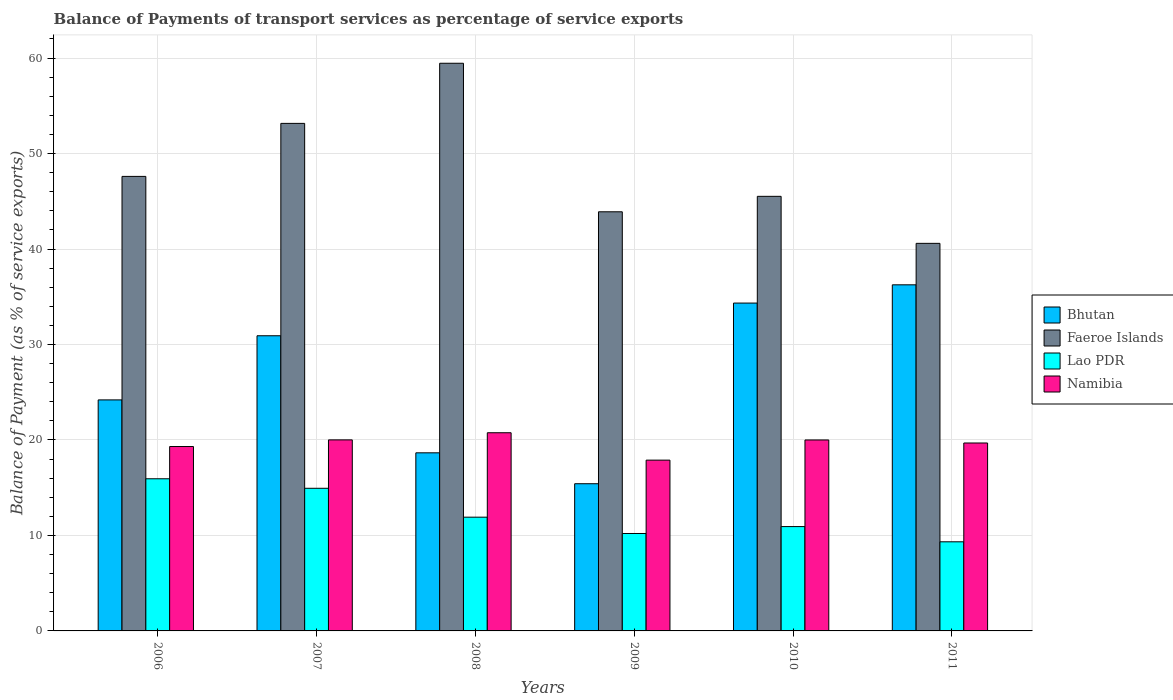How many different coloured bars are there?
Make the answer very short. 4. Are the number of bars per tick equal to the number of legend labels?
Provide a short and direct response. Yes. Are the number of bars on each tick of the X-axis equal?
Your answer should be compact. Yes. In how many cases, is the number of bars for a given year not equal to the number of legend labels?
Offer a very short reply. 0. What is the balance of payments of transport services in Faeroe Islands in 2007?
Offer a very short reply. 53.16. Across all years, what is the maximum balance of payments of transport services in Faeroe Islands?
Offer a very short reply. 59.46. Across all years, what is the minimum balance of payments of transport services in Faeroe Islands?
Your answer should be very brief. 40.59. In which year was the balance of payments of transport services in Faeroe Islands minimum?
Make the answer very short. 2011. What is the total balance of payments of transport services in Faeroe Islands in the graph?
Offer a terse response. 290.24. What is the difference between the balance of payments of transport services in Faeroe Islands in 2009 and that in 2010?
Provide a succinct answer. -1.62. What is the difference between the balance of payments of transport services in Lao PDR in 2011 and the balance of payments of transport services in Namibia in 2010?
Make the answer very short. -10.67. What is the average balance of payments of transport services in Faeroe Islands per year?
Ensure brevity in your answer.  48.37. In the year 2010, what is the difference between the balance of payments of transport services in Bhutan and balance of payments of transport services in Namibia?
Provide a succinct answer. 14.34. What is the ratio of the balance of payments of transport services in Bhutan in 2006 to that in 2011?
Make the answer very short. 0.67. Is the balance of payments of transport services in Namibia in 2007 less than that in 2008?
Provide a short and direct response. Yes. Is the difference between the balance of payments of transport services in Bhutan in 2007 and 2008 greater than the difference between the balance of payments of transport services in Namibia in 2007 and 2008?
Provide a short and direct response. Yes. What is the difference between the highest and the second highest balance of payments of transport services in Namibia?
Keep it short and to the point. 0.75. What is the difference between the highest and the lowest balance of payments of transport services in Namibia?
Your response must be concise. 2.87. Is the sum of the balance of payments of transport services in Lao PDR in 2007 and 2010 greater than the maximum balance of payments of transport services in Bhutan across all years?
Offer a terse response. No. What does the 4th bar from the left in 2007 represents?
Give a very brief answer. Namibia. What does the 3rd bar from the right in 2009 represents?
Provide a short and direct response. Faeroe Islands. How many bars are there?
Provide a succinct answer. 24. What is the difference between two consecutive major ticks on the Y-axis?
Make the answer very short. 10. Are the values on the major ticks of Y-axis written in scientific E-notation?
Ensure brevity in your answer.  No. Does the graph contain any zero values?
Provide a succinct answer. No. Does the graph contain grids?
Offer a very short reply. Yes. How many legend labels are there?
Provide a succinct answer. 4. How are the legend labels stacked?
Provide a short and direct response. Vertical. What is the title of the graph?
Provide a short and direct response. Balance of Payments of transport services as percentage of service exports. What is the label or title of the X-axis?
Provide a short and direct response. Years. What is the label or title of the Y-axis?
Your response must be concise. Balance of Payment (as % of service exports). What is the Balance of Payment (as % of service exports) in Bhutan in 2006?
Your response must be concise. 24.2. What is the Balance of Payment (as % of service exports) in Faeroe Islands in 2006?
Provide a short and direct response. 47.61. What is the Balance of Payment (as % of service exports) of Lao PDR in 2006?
Your answer should be very brief. 15.94. What is the Balance of Payment (as % of service exports) of Namibia in 2006?
Your answer should be compact. 19.31. What is the Balance of Payment (as % of service exports) of Bhutan in 2007?
Offer a terse response. 30.92. What is the Balance of Payment (as % of service exports) in Faeroe Islands in 2007?
Ensure brevity in your answer.  53.16. What is the Balance of Payment (as % of service exports) in Lao PDR in 2007?
Offer a very short reply. 14.94. What is the Balance of Payment (as % of service exports) in Namibia in 2007?
Provide a short and direct response. 20.01. What is the Balance of Payment (as % of service exports) of Bhutan in 2008?
Ensure brevity in your answer.  18.65. What is the Balance of Payment (as % of service exports) in Faeroe Islands in 2008?
Give a very brief answer. 59.46. What is the Balance of Payment (as % of service exports) in Lao PDR in 2008?
Provide a succinct answer. 11.91. What is the Balance of Payment (as % of service exports) in Namibia in 2008?
Provide a short and direct response. 20.76. What is the Balance of Payment (as % of service exports) of Bhutan in 2009?
Offer a terse response. 15.42. What is the Balance of Payment (as % of service exports) of Faeroe Islands in 2009?
Give a very brief answer. 43.9. What is the Balance of Payment (as % of service exports) of Lao PDR in 2009?
Make the answer very short. 10.2. What is the Balance of Payment (as % of service exports) of Namibia in 2009?
Offer a terse response. 17.89. What is the Balance of Payment (as % of service exports) in Bhutan in 2010?
Offer a terse response. 34.34. What is the Balance of Payment (as % of service exports) in Faeroe Islands in 2010?
Provide a succinct answer. 45.52. What is the Balance of Payment (as % of service exports) of Lao PDR in 2010?
Make the answer very short. 10.93. What is the Balance of Payment (as % of service exports) in Namibia in 2010?
Provide a short and direct response. 20. What is the Balance of Payment (as % of service exports) in Bhutan in 2011?
Your answer should be compact. 36.25. What is the Balance of Payment (as % of service exports) in Faeroe Islands in 2011?
Provide a succinct answer. 40.59. What is the Balance of Payment (as % of service exports) of Lao PDR in 2011?
Offer a very short reply. 9.33. What is the Balance of Payment (as % of service exports) of Namibia in 2011?
Offer a very short reply. 19.68. Across all years, what is the maximum Balance of Payment (as % of service exports) of Bhutan?
Ensure brevity in your answer.  36.25. Across all years, what is the maximum Balance of Payment (as % of service exports) of Faeroe Islands?
Ensure brevity in your answer.  59.46. Across all years, what is the maximum Balance of Payment (as % of service exports) in Lao PDR?
Ensure brevity in your answer.  15.94. Across all years, what is the maximum Balance of Payment (as % of service exports) of Namibia?
Your answer should be compact. 20.76. Across all years, what is the minimum Balance of Payment (as % of service exports) in Bhutan?
Ensure brevity in your answer.  15.42. Across all years, what is the minimum Balance of Payment (as % of service exports) in Faeroe Islands?
Keep it short and to the point. 40.59. Across all years, what is the minimum Balance of Payment (as % of service exports) of Lao PDR?
Provide a succinct answer. 9.33. Across all years, what is the minimum Balance of Payment (as % of service exports) in Namibia?
Offer a very short reply. 17.89. What is the total Balance of Payment (as % of service exports) in Bhutan in the graph?
Your answer should be very brief. 159.78. What is the total Balance of Payment (as % of service exports) of Faeroe Islands in the graph?
Your response must be concise. 290.24. What is the total Balance of Payment (as % of service exports) in Lao PDR in the graph?
Offer a very short reply. 73.25. What is the total Balance of Payment (as % of service exports) in Namibia in the graph?
Make the answer very short. 117.66. What is the difference between the Balance of Payment (as % of service exports) in Bhutan in 2006 and that in 2007?
Offer a very short reply. -6.72. What is the difference between the Balance of Payment (as % of service exports) in Faeroe Islands in 2006 and that in 2007?
Keep it short and to the point. -5.55. What is the difference between the Balance of Payment (as % of service exports) of Namibia in 2006 and that in 2007?
Your answer should be very brief. -0.7. What is the difference between the Balance of Payment (as % of service exports) in Bhutan in 2006 and that in 2008?
Provide a succinct answer. 5.54. What is the difference between the Balance of Payment (as % of service exports) of Faeroe Islands in 2006 and that in 2008?
Provide a short and direct response. -11.85. What is the difference between the Balance of Payment (as % of service exports) in Lao PDR in 2006 and that in 2008?
Your response must be concise. 4.02. What is the difference between the Balance of Payment (as % of service exports) in Namibia in 2006 and that in 2008?
Ensure brevity in your answer.  -1.44. What is the difference between the Balance of Payment (as % of service exports) of Bhutan in 2006 and that in 2009?
Give a very brief answer. 8.78. What is the difference between the Balance of Payment (as % of service exports) of Faeroe Islands in 2006 and that in 2009?
Offer a very short reply. 3.71. What is the difference between the Balance of Payment (as % of service exports) of Lao PDR in 2006 and that in 2009?
Give a very brief answer. 5.73. What is the difference between the Balance of Payment (as % of service exports) in Namibia in 2006 and that in 2009?
Your response must be concise. 1.43. What is the difference between the Balance of Payment (as % of service exports) of Bhutan in 2006 and that in 2010?
Your answer should be compact. -10.14. What is the difference between the Balance of Payment (as % of service exports) of Faeroe Islands in 2006 and that in 2010?
Keep it short and to the point. 2.09. What is the difference between the Balance of Payment (as % of service exports) of Lao PDR in 2006 and that in 2010?
Ensure brevity in your answer.  5.01. What is the difference between the Balance of Payment (as % of service exports) of Namibia in 2006 and that in 2010?
Your response must be concise. -0.69. What is the difference between the Balance of Payment (as % of service exports) in Bhutan in 2006 and that in 2011?
Your answer should be compact. -12.05. What is the difference between the Balance of Payment (as % of service exports) in Faeroe Islands in 2006 and that in 2011?
Give a very brief answer. 7.01. What is the difference between the Balance of Payment (as % of service exports) in Lao PDR in 2006 and that in 2011?
Give a very brief answer. 6.6. What is the difference between the Balance of Payment (as % of service exports) of Namibia in 2006 and that in 2011?
Provide a succinct answer. -0.37. What is the difference between the Balance of Payment (as % of service exports) in Bhutan in 2007 and that in 2008?
Keep it short and to the point. 12.26. What is the difference between the Balance of Payment (as % of service exports) of Faeroe Islands in 2007 and that in 2008?
Make the answer very short. -6.3. What is the difference between the Balance of Payment (as % of service exports) in Lao PDR in 2007 and that in 2008?
Offer a very short reply. 3.02. What is the difference between the Balance of Payment (as % of service exports) of Namibia in 2007 and that in 2008?
Your answer should be compact. -0.75. What is the difference between the Balance of Payment (as % of service exports) of Bhutan in 2007 and that in 2009?
Give a very brief answer. 15.5. What is the difference between the Balance of Payment (as % of service exports) in Faeroe Islands in 2007 and that in 2009?
Your answer should be compact. 9.26. What is the difference between the Balance of Payment (as % of service exports) in Lao PDR in 2007 and that in 2009?
Give a very brief answer. 4.73. What is the difference between the Balance of Payment (as % of service exports) of Namibia in 2007 and that in 2009?
Your answer should be very brief. 2.12. What is the difference between the Balance of Payment (as % of service exports) of Bhutan in 2007 and that in 2010?
Your response must be concise. -3.42. What is the difference between the Balance of Payment (as % of service exports) of Faeroe Islands in 2007 and that in 2010?
Your response must be concise. 7.64. What is the difference between the Balance of Payment (as % of service exports) in Lao PDR in 2007 and that in 2010?
Provide a succinct answer. 4.01. What is the difference between the Balance of Payment (as % of service exports) of Namibia in 2007 and that in 2010?
Offer a very short reply. 0.01. What is the difference between the Balance of Payment (as % of service exports) in Bhutan in 2007 and that in 2011?
Keep it short and to the point. -5.33. What is the difference between the Balance of Payment (as % of service exports) in Faeroe Islands in 2007 and that in 2011?
Keep it short and to the point. 12.57. What is the difference between the Balance of Payment (as % of service exports) of Lao PDR in 2007 and that in 2011?
Your response must be concise. 5.6. What is the difference between the Balance of Payment (as % of service exports) in Namibia in 2007 and that in 2011?
Make the answer very short. 0.33. What is the difference between the Balance of Payment (as % of service exports) of Bhutan in 2008 and that in 2009?
Make the answer very short. 3.24. What is the difference between the Balance of Payment (as % of service exports) of Faeroe Islands in 2008 and that in 2009?
Your answer should be very brief. 15.56. What is the difference between the Balance of Payment (as % of service exports) in Lao PDR in 2008 and that in 2009?
Ensure brevity in your answer.  1.71. What is the difference between the Balance of Payment (as % of service exports) of Namibia in 2008 and that in 2009?
Give a very brief answer. 2.87. What is the difference between the Balance of Payment (as % of service exports) in Bhutan in 2008 and that in 2010?
Give a very brief answer. -15.68. What is the difference between the Balance of Payment (as % of service exports) in Faeroe Islands in 2008 and that in 2010?
Ensure brevity in your answer.  13.94. What is the difference between the Balance of Payment (as % of service exports) of Lao PDR in 2008 and that in 2010?
Your response must be concise. 0.99. What is the difference between the Balance of Payment (as % of service exports) in Namibia in 2008 and that in 2010?
Offer a terse response. 0.76. What is the difference between the Balance of Payment (as % of service exports) in Bhutan in 2008 and that in 2011?
Your response must be concise. -17.6. What is the difference between the Balance of Payment (as % of service exports) in Faeroe Islands in 2008 and that in 2011?
Make the answer very short. 18.86. What is the difference between the Balance of Payment (as % of service exports) of Lao PDR in 2008 and that in 2011?
Offer a very short reply. 2.58. What is the difference between the Balance of Payment (as % of service exports) of Namibia in 2008 and that in 2011?
Give a very brief answer. 1.07. What is the difference between the Balance of Payment (as % of service exports) in Bhutan in 2009 and that in 2010?
Your answer should be compact. -18.92. What is the difference between the Balance of Payment (as % of service exports) in Faeroe Islands in 2009 and that in 2010?
Offer a very short reply. -1.62. What is the difference between the Balance of Payment (as % of service exports) in Lao PDR in 2009 and that in 2010?
Your answer should be very brief. -0.72. What is the difference between the Balance of Payment (as % of service exports) in Namibia in 2009 and that in 2010?
Your response must be concise. -2.11. What is the difference between the Balance of Payment (as % of service exports) of Bhutan in 2009 and that in 2011?
Provide a succinct answer. -20.83. What is the difference between the Balance of Payment (as % of service exports) in Faeroe Islands in 2009 and that in 2011?
Your answer should be compact. 3.31. What is the difference between the Balance of Payment (as % of service exports) in Lao PDR in 2009 and that in 2011?
Offer a terse response. 0.87. What is the difference between the Balance of Payment (as % of service exports) of Namibia in 2009 and that in 2011?
Ensure brevity in your answer.  -1.79. What is the difference between the Balance of Payment (as % of service exports) of Bhutan in 2010 and that in 2011?
Offer a very short reply. -1.91. What is the difference between the Balance of Payment (as % of service exports) in Faeroe Islands in 2010 and that in 2011?
Offer a terse response. 4.92. What is the difference between the Balance of Payment (as % of service exports) of Lao PDR in 2010 and that in 2011?
Your response must be concise. 1.59. What is the difference between the Balance of Payment (as % of service exports) of Namibia in 2010 and that in 2011?
Keep it short and to the point. 0.32. What is the difference between the Balance of Payment (as % of service exports) of Bhutan in 2006 and the Balance of Payment (as % of service exports) of Faeroe Islands in 2007?
Keep it short and to the point. -28.96. What is the difference between the Balance of Payment (as % of service exports) in Bhutan in 2006 and the Balance of Payment (as % of service exports) in Lao PDR in 2007?
Offer a very short reply. 9.26. What is the difference between the Balance of Payment (as % of service exports) of Bhutan in 2006 and the Balance of Payment (as % of service exports) of Namibia in 2007?
Keep it short and to the point. 4.19. What is the difference between the Balance of Payment (as % of service exports) in Faeroe Islands in 2006 and the Balance of Payment (as % of service exports) in Lao PDR in 2007?
Make the answer very short. 32.67. What is the difference between the Balance of Payment (as % of service exports) of Faeroe Islands in 2006 and the Balance of Payment (as % of service exports) of Namibia in 2007?
Your response must be concise. 27.6. What is the difference between the Balance of Payment (as % of service exports) of Lao PDR in 2006 and the Balance of Payment (as % of service exports) of Namibia in 2007?
Give a very brief answer. -4.07. What is the difference between the Balance of Payment (as % of service exports) of Bhutan in 2006 and the Balance of Payment (as % of service exports) of Faeroe Islands in 2008?
Your response must be concise. -35.26. What is the difference between the Balance of Payment (as % of service exports) of Bhutan in 2006 and the Balance of Payment (as % of service exports) of Lao PDR in 2008?
Your response must be concise. 12.28. What is the difference between the Balance of Payment (as % of service exports) in Bhutan in 2006 and the Balance of Payment (as % of service exports) in Namibia in 2008?
Your response must be concise. 3.44. What is the difference between the Balance of Payment (as % of service exports) in Faeroe Islands in 2006 and the Balance of Payment (as % of service exports) in Lao PDR in 2008?
Provide a succinct answer. 35.69. What is the difference between the Balance of Payment (as % of service exports) of Faeroe Islands in 2006 and the Balance of Payment (as % of service exports) of Namibia in 2008?
Ensure brevity in your answer.  26.85. What is the difference between the Balance of Payment (as % of service exports) of Lao PDR in 2006 and the Balance of Payment (as % of service exports) of Namibia in 2008?
Make the answer very short. -4.82. What is the difference between the Balance of Payment (as % of service exports) in Bhutan in 2006 and the Balance of Payment (as % of service exports) in Faeroe Islands in 2009?
Offer a terse response. -19.7. What is the difference between the Balance of Payment (as % of service exports) of Bhutan in 2006 and the Balance of Payment (as % of service exports) of Lao PDR in 2009?
Keep it short and to the point. 13.99. What is the difference between the Balance of Payment (as % of service exports) of Bhutan in 2006 and the Balance of Payment (as % of service exports) of Namibia in 2009?
Give a very brief answer. 6.31. What is the difference between the Balance of Payment (as % of service exports) in Faeroe Islands in 2006 and the Balance of Payment (as % of service exports) in Lao PDR in 2009?
Make the answer very short. 37.4. What is the difference between the Balance of Payment (as % of service exports) of Faeroe Islands in 2006 and the Balance of Payment (as % of service exports) of Namibia in 2009?
Your answer should be compact. 29.72. What is the difference between the Balance of Payment (as % of service exports) of Lao PDR in 2006 and the Balance of Payment (as % of service exports) of Namibia in 2009?
Your response must be concise. -1.95. What is the difference between the Balance of Payment (as % of service exports) of Bhutan in 2006 and the Balance of Payment (as % of service exports) of Faeroe Islands in 2010?
Ensure brevity in your answer.  -21.32. What is the difference between the Balance of Payment (as % of service exports) of Bhutan in 2006 and the Balance of Payment (as % of service exports) of Lao PDR in 2010?
Provide a succinct answer. 13.27. What is the difference between the Balance of Payment (as % of service exports) in Bhutan in 2006 and the Balance of Payment (as % of service exports) in Namibia in 2010?
Offer a terse response. 4.2. What is the difference between the Balance of Payment (as % of service exports) in Faeroe Islands in 2006 and the Balance of Payment (as % of service exports) in Lao PDR in 2010?
Offer a terse response. 36.68. What is the difference between the Balance of Payment (as % of service exports) in Faeroe Islands in 2006 and the Balance of Payment (as % of service exports) in Namibia in 2010?
Offer a very short reply. 27.6. What is the difference between the Balance of Payment (as % of service exports) of Lao PDR in 2006 and the Balance of Payment (as % of service exports) of Namibia in 2010?
Make the answer very short. -4.06. What is the difference between the Balance of Payment (as % of service exports) in Bhutan in 2006 and the Balance of Payment (as % of service exports) in Faeroe Islands in 2011?
Your answer should be very brief. -16.4. What is the difference between the Balance of Payment (as % of service exports) in Bhutan in 2006 and the Balance of Payment (as % of service exports) in Lao PDR in 2011?
Your answer should be very brief. 14.86. What is the difference between the Balance of Payment (as % of service exports) of Bhutan in 2006 and the Balance of Payment (as % of service exports) of Namibia in 2011?
Offer a terse response. 4.51. What is the difference between the Balance of Payment (as % of service exports) in Faeroe Islands in 2006 and the Balance of Payment (as % of service exports) in Lao PDR in 2011?
Ensure brevity in your answer.  38.27. What is the difference between the Balance of Payment (as % of service exports) in Faeroe Islands in 2006 and the Balance of Payment (as % of service exports) in Namibia in 2011?
Provide a succinct answer. 27.92. What is the difference between the Balance of Payment (as % of service exports) of Lao PDR in 2006 and the Balance of Payment (as % of service exports) of Namibia in 2011?
Keep it short and to the point. -3.75. What is the difference between the Balance of Payment (as % of service exports) of Bhutan in 2007 and the Balance of Payment (as % of service exports) of Faeroe Islands in 2008?
Offer a terse response. -28.54. What is the difference between the Balance of Payment (as % of service exports) of Bhutan in 2007 and the Balance of Payment (as % of service exports) of Lao PDR in 2008?
Offer a very short reply. 19. What is the difference between the Balance of Payment (as % of service exports) in Bhutan in 2007 and the Balance of Payment (as % of service exports) in Namibia in 2008?
Your answer should be very brief. 10.16. What is the difference between the Balance of Payment (as % of service exports) in Faeroe Islands in 2007 and the Balance of Payment (as % of service exports) in Lao PDR in 2008?
Your answer should be compact. 41.25. What is the difference between the Balance of Payment (as % of service exports) in Faeroe Islands in 2007 and the Balance of Payment (as % of service exports) in Namibia in 2008?
Your response must be concise. 32.4. What is the difference between the Balance of Payment (as % of service exports) in Lao PDR in 2007 and the Balance of Payment (as % of service exports) in Namibia in 2008?
Make the answer very short. -5.82. What is the difference between the Balance of Payment (as % of service exports) in Bhutan in 2007 and the Balance of Payment (as % of service exports) in Faeroe Islands in 2009?
Your response must be concise. -12.98. What is the difference between the Balance of Payment (as % of service exports) in Bhutan in 2007 and the Balance of Payment (as % of service exports) in Lao PDR in 2009?
Your answer should be compact. 20.71. What is the difference between the Balance of Payment (as % of service exports) of Bhutan in 2007 and the Balance of Payment (as % of service exports) of Namibia in 2009?
Keep it short and to the point. 13.03. What is the difference between the Balance of Payment (as % of service exports) in Faeroe Islands in 2007 and the Balance of Payment (as % of service exports) in Lao PDR in 2009?
Your response must be concise. 42.96. What is the difference between the Balance of Payment (as % of service exports) in Faeroe Islands in 2007 and the Balance of Payment (as % of service exports) in Namibia in 2009?
Your answer should be very brief. 35.27. What is the difference between the Balance of Payment (as % of service exports) in Lao PDR in 2007 and the Balance of Payment (as % of service exports) in Namibia in 2009?
Offer a terse response. -2.95. What is the difference between the Balance of Payment (as % of service exports) in Bhutan in 2007 and the Balance of Payment (as % of service exports) in Faeroe Islands in 2010?
Offer a terse response. -14.6. What is the difference between the Balance of Payment (as % of service exports) of Bhutan in 2007 and the Balance of Payment (as % of service exports) of Lao PDR in 2010?
Your response must be concise. 19.99. What is the difference between the Balance of Payment (as % of service exports) of Bhutan in 2007 and the Balance of Payment (as % of service exports) of Namibia in 2010?
Provide a short and direct response. 10.91. What is the difference between the Balance of Payment (as % of service exports) of Faeroe Islands in 2007 and the Balance of Payment (as % of service exports) of Lao PDR in 2010?
Your answer should be compact. 42.23. What is the difference between the Balance of Payment (as % of service exports) of Faeroe Islands in 2007 and the Balance of Payment (as % of service exports) of Namibia in 2010?
Your answer should be compact. 33.16. What is the difference between the Balance of Payment (as % of service exports) in Lao PDR in 2007 and the Balance of Payment (as % of service exports) in Namibia in 2010?
Ensure brevity in your answer.  -5.06. What is the difference between the Balance of Payment (as % of service exports) of Bhutan in 2007 and the Balance of Payment (as % of service exports) of Faeroe Islands in 2011?
Give a very brief answer. -9.68. What is the difference between the Balance of Payment (as % of service exports) of Bhutan in 2007 and the Balance of Payment (as % of service exports) of Lao PDR in 2011?
Offer a very short reply. 21.58. What is the difference between the Balance of Payment (as % of service exports) in Bhutan in 2007 and the Balance of Payment (as % of service exports) in Namibia in 2011?
Offer a terse response. 11.23. What is the difference between the Balance of Payment (as % of service exports) of Faeroe Islands in 2007 and the Balance of Payment (as % of service exports) of Lao PDR in 2011?
Ensure brevity in your answer.  43.83. What is the difference between the Balance of Payment (as % of service exports) in Faeroe Islands in 2007 and the Balance of Payment (as % of service exports) in Namibia in 2011?
Keep it short and to the point. 33.48. What is the difference between the Balance of Payment (as % of service exports) in Lao PDR in 2007 and the Balance of Payment (as % of service exports) in Namibia in 2011?
Make the answer very short. -4.75. What is the difference between the Balance of Payment (as % of service exports) of Bhutan in 2008 and the Balance of Payment (as % of service exports) of Faeroe Islands in 2009?
Provide a short and direct response. -25.25. What is the difference between the Balance of Payment (as % of service exports) in Bhutan in 2008 and the Balance of Payment (as % of service exports) in Lao PDR in 2009?
Ensure brevity in your answer.  8.45. What is the difference between the Balance of Payment (as % of service exports) in Bhutan in 2008 and the Balance of Payment (as % of service exports) in Namibia in 2009?
Give a very brief answer. 0.77. What is the difference between the Balance of Payment (as % of service exports) of Faeroe Islands in 2008 and the Balance of Payment (as % of service exports) of Lao PDR in 2009?
Give a very brief answer. 49.25. What is the difference between the Balance of Payment (as % of service exports) of Faeroe Islands in 2008 and the Balance of Payment (as % of service exports) of Namibia in 2009?
Offer a terse response. 41.57. What is the difference between the Balance of Payment (as % of service exports) in Lao PDR in 2008 and the Balance of Payment (as % of service exports) in Namibia in 2009?
Ensure brevity in your answer.  -5.97. What is the difference between the Balance of Payment (as % of service exports) in Bhutan in 2008 and the Balance of Payment (as % of service exports) in Faeroe Islands in 2010?
Provide a short and direct response. -26.86. What is the difference between the Balance of Payment (as % of service exports) in Bhutan in 2008 and the Balance of Payment (as % of service exports) in Lao PDR in 2010?
Provide a short and direct response. 7.73. What is the difference between the Balance of Payment (as % of service exports) of Bhutan in 2008 and the Balance of Payment (as % of service exports) of Namibia in 2010?
Your answer should be compact. -1.35. What is the difference between the Balance of Payment (as % of service exports) of Faeroe Islands in 2008 and the Balance of Payment (as % of service exports) of Lao PDR in 2010?
Offer a very short reply. 48.53. What is the difference between the Balance of Payment (as % of service exports) of Faeroe Islands in 2008 and the Balance of Payment (as % of service exports) of Namibia in 2010?
Give a very brief answer. 39.46. What is the difference between the Balance of Payment (as % of service exports) of Lao PDR in 2008 and the Balance of Payment (as % of service exports) of Namibia in 2010?
Your response must be concise. -8.09. What is the difference between the Balance of Payment (as % of service exports) of Bhutan in 2008 and the Balance of Payment (as % of service exports) of Faeroe Islands in 2011?
Your response must be concise. -21.94. What is the difference between the Balance of Payment (as % of service exports) in Bhutan in 2008 and the Balance of Payment (as % of service exports) in Lao PDR in 2011?
Offer a terse response. 9.32. What is the difference between the Balance of Payment (as % of service exports) in Bhutan in 2008 and the Balance of Payment (as % of service exports) in Namibia in 2011?
Make the answer very short. -1.03. What is the difference between the Balance of Payment (as % of service exports) of Faeroe Islands in 2008 and the Balance of Payment (as % of service exports) of Lao PDR in 2011?
Give a very brief answer. 50.12. What is the difference between the Balance of Payment (as % of service exports) in Faeroe Islands in 2008 and the Balance of Payment (as % of service exports) in Namibia in 2011?
Provide a short and direct response. 39.77. What is the difference between the Balance of Payment (as % of service exports) of Lao PDR in 2008 and the Balance of Payment (as % of service exports) of Namibia in 2011?
Offer a terse response. -7.77. What is the difference between the Balance of Payment (as % of service exports) of Bhutan in 2009 and the Balance of Payment (as % of service exports) of Faeroe Islands in 2010?
Your answer should be compact. -30.1. What is the difference between the Balance of Payment (as % of service exports) in Bhutan in 2009 and the Balance of Payment (as % of service exports) in Lao PDR in 2010?
Make the answer very short. 4.49. What is the difference between the Balance of Payment (as % of service exports) in Bhutan in 2009 and the Balance of Payment (as % of service exports) in Namibia in 2010?
Your answer should be very brief. -4.58. What is the difference between the Balance of Payment (as % of service exports) of Faeroe Islands in 2009 and the Balance of Payment (as % of service exports) of Lao PDR in 2010?
Keep it short and to the point. 32.97. What is the difference between the Balance of Payment (as % of service exports) of Faeroe Islands in 2009 and the Balance of Payment (as % of service exports) of Namibia in 2010?
Keep it short and to the point. 23.9. What is the difference between the Balance of Payment (as % of service exports) in Lao PDR in 2009 and the Balance of Payment (as % of service exports) in Namibia in 2010?
Your answer should be very brief. -9.8. What is the difference between the Balance of Payment (as % of service exports) of Bhutan in 2009 and the Balance of Payment (as % of service exports) of Faeroe Islands in 2011?
Offer a very short reply. -25.18. What is the difference between the Balance of Payment (as % of service exports) in Bhutan in 2009 and the Balance of Payment (as % of service exports) in Lao PDR in 2011?
Your answer should be compact. 6.08. What is the difference between the Balance of Payment (as % of service exports) in Bhutan in 2009 and the Balance of Payment (as % of service exports) in Namibia in 2011?
Offer a very short reply. -4.27. What is the difference between the Balance of Payment (as % of service exports) of Faeroe Islands in 2009 and the Balance of Payment (as % of service exports) of Lao PDR in 2011?
Your response must be concise. 34.57. What is the difference between the Balance of Payment (as % of service exports) in Faeroe Islands in 2009 and the Balance of Payment (as % of service exports) in Namibia in 2011?
Offer a very short reply. 24.22. What is the difference between the Balance of Payment (as % of service exports) of Lao PDR in 2009 and the Balance of Payment (as % of service exports) of Namibia in 2011?
Provide a succinct answer. -9.48. What is the difference between the Balance of Payment (as % of service exports) of Bhutan in 2010 and the Balance of Payment (as % of service exports) of Faeroe Islands in 2011?
Provide a short and direct response. -6.26. What is the difference between the Balance of Payment (as % of service exports) in Bhutan in 2010 and the Balance of Payment (as % of service exports) in Lao PDR in 2011?
Your response must be concise. 25. What is the difference between the Balance of Payment (as % of service exports) in Bhutan in 2010 and the Balance of Payment (as % of service exports) in Namibia in 2011?
Your response must be concise. 14.66. What is the difference between the Balance of Payment (as % of service exports) in Faeroe Islands in 2010 and the Balance of Payment (as % of service exports) in Lao PDR in 2011?
Offer a very short reply. 36.18. What is the difference between the Balance of Payment (as % of service exports) in Faeroe Islands in 2010 and the Balance of Payment (as % of service exports) in Namibia in 2011?
Your response must be concise. 25.84. What is the difference between the Balance of Payment (as % of service exports) in Lao PDR in 2010 and the Balance of Payment (as % of service exports) in Namibia in 2011?
Your answer should be very brief. -8.76. What is the average Balance of Payment (as % of service exports) in Bhutan per year?
Offer a very short reply. 26.63. What is the average Balance of Payment (as % of service exports) in Faeroe Islands per year?
Offer a terse response. 48.37. What is the average Balance of Payment (as % of service exports) in Lao PDR per year?
Your response must be concise. 12.21. What is the average Balance of Payment (as % of service exports) of Namibia per year?
Your answer should be compact. 19.61. In the year 2006, what is the difference between the Balance of Payment (as % of service exports) in Bhutan and Balance of Payment (as % of service exports) in Faeroe Islands?
Provide a succinct answer. -23.41. In the year 2006, what is the difference between the Balance of Payment (as % of service exports) in Bhutan and Balance of Payment (as % of service exports) in Lao PDR?
Ensure brevity in your answer.  8.26. In the year 2006, what is the difference between the Balance of Payment (as % of service exports) in Bhutan and Balance of Payment (as % of service exports) in Namibia?
Keep it short and to the point. 4.88. In the year 2006, what is the difference between the Balance of Payment (as % of service exports) of Faeroe Islands and Balance of Payment (as % of service exports) of Lao PDR?
Keep it short and to the point. 31.67. In the year 2006, what is the difference between the Balance of Payment (as % of service exports) in Faeroe Islands and Balance of Payment (as % of service exports) in Namibia?
Your response must be concise. 28.29. In the year 2006, what is the difference between the Balance of Payment (as % of service exports) of Lao PDR and Balance of Payment (as % of service exports) of Namibia?
Offer a terse response. -3.38. In the year 2007, what is the difference between the Balance of Payment (as % of service exports) of Bhutan and Balance of Payment (as % of service exports) of Faeroe Islands?
Offer a very short reply. -22.24. In the year 2007, what is the difference between the Balance of Payment (as % of service exports) in Bhutan and Balance of Payment (as % of service exports) in Lao PDR?
Make the answer very short. 15.98. In the year 2007, what is the difference between the Balance of Payment (as % of service exports) of Bhutan and Balance of Payment (as % of service exports) of Namibia?
Provide a short and direct response. 10.91. In the year 2007, what is the difference between the Balance of Payment (as % of service exports) in Faeroe Islands and Balance of Payment (as % of service exports) in Lao PDR?
Provide a short and direct response. 38.22. In the year 2007, what is the difference between the Balance of Payment (as % of service exports) of Faeroe Islands and Balance of Payment (as % of service exports) of Namibia?
Make the answer very short. 33.15. In the year 2007, what is the difference between the Balance of Payment (as % of service exports) in Lao PDR and Balance of Payment (as % of service exports) in Namibia?
Offer a terse response. -5.07. In the year 2008, what is the difference between the Balance of Payment (as % of service exports) of Bhutan and Balance of Payment (as % of service exports) of Faeroe Islands?
Give a very brief answer. -40.8. In the year 2008, what is the difference between the Balance of Payment (as % of service exports) in Bhutan and Balance of Payment (as % of service exports) in Lao PDR?
Your answer should be compact. 6.74. In the year 2008, what is the difference between the Balance of Payment (as % of service exports) of Bhutan and Balance of Payment (as % of service exports) of Namibia?
Ensure brevity in your answer.  -2.1. In the year 2008, what is the difference between the Balance of Payment (as % of service exports) in Faeroe Islands and Balance of Payment (as % of service exports) in Lao PDR?
Provide a succinct answer. 47.54. In the year 2008, what is the difference between the Balance of Payment (as % of service exports) of Faeroe Islands and Balance of Payment (as % of service exports) of Namibia?
Ensure brevity in your answer.  38.7. In the year 2008, what is the difference between the Balance of Payment (as % of service exports) of Lao PDR and Balance of Payment (as % of service exports) of Namibia?
Make the answer very short. -8.84. In the year 2009, what is the difference between the Balance of Payment (as % of service exports) of Bhutan and Balance of Payment (as % of service exports) of Faeroe Islands?
Make the answer very short. -28.48. In the year 2009, what is the difference between the Balance of Payment (as % of service exports) in Bhutan and Balance of Payment (as % of service exports) in Lao PDR?
Make the answer very short. 5.21. In the year 2009, what is the difference between the Balance of Payment (as % of service exports) of Bhutan and Balance of Payment (as % of service exports) of Namibia?
Keep it short and to the point. -2.47. In the year 2009, what is the difference between the Balance of Payment (as % of service exports) of Faeroe Islands and Balance of Payment (as % of service exports) of Lao PDR?
Give a very brief answer. 33.7. In the year 2009, what is the difference between the Balance of Payment (as % of service exports) of Faeroe Islands and Balance of Payment (as % of service exports) of Namibia?
Your answer should be compact. 26.01. In the year 2009, what is the difference between the Balance of Payment (as % of service exports) of Lao PDR and Balance of Payment (as % of service exports) of Namibia?
Provide a short and direct response. -7.68. In the year 2010, what is the difference between the Balance of Payment (as % of service exports) of Bhutan and Balance of Payment (as % of service exports) of Faeroe Islands?
Your answer should be very brief. -11.18. In the year 2010, what is the difference between the Balance of Payment (as % of service exports) in Bhutan and Balance of Payment (as % of service exports) in Lao PDR?
Your answer should be very brief. 23.41. In the year 2010, what is the difference between the Balance of Payment (as % of service exports) in Bhutan and Balance of Payment (as % of service exports) in Namibia?
Provide a short and direct response. 14.34. In the year 2010, what is the difference between the Balance of Payment (as % of service exports) in Faeroe Islands and Balance of Payment (as % of service exports) in Lao PDR?
Offer a terse response. 34.59. In the year 2010, what is the difference between the Balance of Payment (as % of service exports) of Faeroe Islands and Balance of Payment (as % of service exports) of Namibia?
Provide a succinct answer. 25.52. In the year 2010, what is the difference between the Balance of Payment (as % of service exports) of Lao PDR and Balance of Payment (as % of service exports) of Namibia?
Give a very brief answer. -9.07. In the year 2011, what is the difference between the Balance of Payment (as % of service exports) in Bhutan and Balance of Payment (as % of service exports) in Faeroe Islands?
Ensure brevity in your answer.  -4.34. In the year 2011, what is the difference between the Balance of Payment (as % of service exports) of Bhutan and Balance of Payment (as % of service exports) of Lao PDR?
Offer a very short reply. 26.92. In the year 2011, what is the difference between the Balance of Payment (as % of service exports) of Bhutan and Balance of Payment (as % of service exports) of Namibia?
Offer a terse response. 16.57. In the year 2011, what is the difference between the Balance of Payment (as % of service exports) of Faeroe Islands and Balance of Payment (as % of service exports) of Lao PDR?
Offer a terse response. 31.26. In the year 2011, what is the difference between the Balance of Payment (as % of service exports) in Faeroe Islands and Balance of Payment (as % of service exports) in Namibia?
Offer a terse response. 20.91. In the year 2011, what is the difference between the Balance of Payment (as % of service exports) in Lao PDR and Balance of Payment (as % of service exports) in Namibia?
Keep it short and to the point. -10.35. What is the ratio of the Balance of Payment (as % of service exports) of Bhutan in 2006 to that in 2007?
Your response must be concise. 0.78. What is the ratio of the Balance of Payment (as % of service exports) in Faeroe Islands in 2006 to that in 2007?
Give a very brief answer. 0.9. What is the ratio of the Balance of Payment (as % of service exports) in Lao PDR in 2006 to that in 2007?
Your response must be concise. 1.07. What is the ratio of the Balance of Payment (as % of service exports) of Namibia in 2006 to that in 2007?
Ensure brevity in your answer.  0.97. What is the ratio of the Balance of Payment (as % of service exports) of Bhutan in 2006 to that in 2008?
Make the answer very short. 1.3. What is the ratio of the Balance of Payment (as % of service exports) in Faeroe Islands in 2006 to that in 2008?
Provide a succinct answer. 0.8. What is the ratio of the Balance of Payment (as % of service exports) in Lao PDR in 2006 to that in 2008?
Offer a terse response. 1.34. What is the ratio of the Balance of Payment (as % of service exports) of Namibia in 2006 to that in 2008?
Keep it short and to the point. 0.93. What is the ratio of the Balance of Payment (as % of service exports) in Bhutan in 2006 to that in 2009?
Make the answer very short. 1.57. What is the ratio of the Balance of Payment (as % of service exports) of Faeroe Islands in 2006 to that in 2009?
Your answer should be compact. 1.08. What is the ratio of the Balance of Payment (as % of service exports) in Lao PDR in 2006 to that in 2009?
Your answer should be compact. 1.56. What is the ratio of the Balance of Payment (as % of service exports) of Namibia in 2006 to that in 2009?
Keep it short and to the point. 1.08. What is the ratio of the Balance of Payment (as % of service exports) of Bhutan in 2006 to that in 2010?
Offer a terse response. 0.7. What is the ratio of the Balance of Payment (as % of service exports) in Faeroe Islands in 2006 to that in 2010?
Provide a succinct answer. 1.05. What is the ratio of the Balance of Payment (as % of service exports) in Lao PDR in 2006 to that in 2010?
Keep it short and to the point. 1.46. What is the ratio of the Balance of Payment (as % of service exports) in Namibia in 2006 to that in 2010?
Ensure brevity in your answer.  0.97. What is the ratio of the Balance of Payment (as % of service exports) in Bhutan in 2006 to that in 2011?
Offer a terse response. 0.67. What is the ratio of the Balance of Payment (as % of service exports) in Faeroe Islands in 2006 to that in 2011?
Your response must be concise. 1.17. What is the ratio of the Balance of Payment (as % of service exports) in Lao PDR in 2006 to that in 2011?
Offer a terse response. 1.71. What is the ratio of the Balance of Payment (as % of service exports) of Namibia in 2006 to that in 2011?
Give a very brief answer. 0.98. What is the ratio of the Balance of Payment (as % of service exports) of Bhutan in 2007 to that in 2008?
Keep it short and to the point. 1.66. What is the ratio of the Balance of Payment (as % of service exports) in Faeroe Islands in 2007 to that in 2008?
Provide a short and direct response. 0.89. What is the ratio of the Balance of Payment (as % of service exports) of Lao PDR in 2007 to that in 2008?
Offer a terse response. 1.25. What is the ratio of the Balance of Payment (as % of service exports) of Namibia in 2007 to that in 2008?
Your answer should be very brief. 0.96. What is the ratio of the Balance of Payment (as % of service exports) of Bhutan in 2007 to that in 2009?
Offer a terse response. 2.01. What is the ratio of the Balance of Payment (as % of service exports) of Faeroe Islands in 2007 to that in 2009?
Provide a short and direct response. 1.21. What is the ratio of the Balance of Payment (as % of service exports) in Lao PDR in 2007 to that in 2009?
Offer a very short reply. 1.46. What is the ratio of the Balance of Payment (as % of service exports) of Namibia in 2007 to that in 2009?
Your answer should be compact. 1.12. What is the ratio of the Balance of Payment (as % of service exports) of Bhutan in 2007 to that in 2010?
Provide a short and direct response. 0.9. What is the ratio of the Balance of Payment (as % of service exports) in Faeroe Islands in 2007 to that in 2010?
Offer a very short reply. 1.17. What is the ratio of the Balance of Payment (as % of service exports) in Lao PDR in 2007 to that in 2010?
Your answer should be very brief. 1.37. What is the ratio of the Balance of Payment (as % of service exports) in Namibia in 2007 to that in 2010?
Your response must be concise. 1. What is the ratio of the Balance of Payment (as % of service exports) of Bhutan in 2007 to that in 2011?
Make the answer very short. 0.85. What is the ratio of the Balance of Payment (as % of service exports) in Faeroe Islands in 2007 to that in 2011?
Your response must be concise. 1.31. What is the ratio of the Balance of Payment (as % of service exports) in Lao PDR in 2007 to that in 2011?
Provide a succinct answer. 1.6. What is the ratio of the Balance of Payment (as % of service exports) of Namibia in 2007 to that in 2011?
Give a very brief answer. 1.02. What is the ratio of the Balance of Payment (as % of service exports) in Bhutan in 2008 to that in 2009?
Offer a very short reply. 1.21. What is the ratio of the Balance of Payment (as % of service exports) of Faeroe Islands in 2008 to that in 2009?
Provide a succinct answer. 1.35. What is the ratio of the Balance of Payment (as % of service exports) in Lao PDR in 2008 to that in 2009?
Offer a very short reply. 1.17. What is the ratio of the Balance of Payment (as % of service exports) of Namibia in 2008 to that in 2009?
Provide a succinct answer. 1.16. What is the ratio of the Balance of Payment (as % of service exports) of Bhutan in 2008 to that in 2010?
Give a very brief answer. 0.54. What is the ratio of the Balance of Payment (as % of service exports) in Faeroe Islands in 2008 to that in 2010?
Offer a terse response. 1.31. What is the ratio of the Balance of Payment (as % of service exports) in Lao PDR in 2008 to that in 2010?
Provide a short and direct response. 1.09. What is the ratio of the Balance of Payment (as % of service exports) of Namibia in 2008 to that in 2010?
Your response must be concise. 1.04. What is the ratio of the Balance of Payment (as % of service exports) of Bhutan in 2008 to that in 2011?
Offer a terse response. 0.51. What is the ratio of the Balance of Payment (as % of service exports) in Faeroe Islands in 2008 to that in 2011?
Your answer should be compact. 1.46. What is the ratio of the Balance of Payment (as % of service exports) of Lao PDR in 2008 to that in 2011?
Offer a terse response. 1.28. What is the ratio of the Balance of Payment (as % of service exports) of Namibia in 2008 to that in 2011?
Your answer should be compact. 1.05. What is the ratio of the Balance of Payment (as % of service exports) of Bhutan in 2009 to that in 2010?
Provide a short and direct response. 0.45. What is the ratio of the Balance of Payment (as % of service exports) in Faeroe Islands in 2009 to that in 2010?
Your answer should be very brief. 0.96. What is the ratio of the Balance of Payment (as % of service exports) of Lao PDR in 2009 to that in 2010?
Keep it short and to the point. 0.93. What is the ratio of the Balance of Payment (as % of service exports) of Namibia in 2009 to that in 2010?
Ensure brevity in your answer.  0.89. What is the ratio of the Balance of Payment (as % of service exports) of Bhutan in 2009 to that in 2011?
Keep it short and to the point. 0.43. What is the ratio of the Balance of Payment (as % of service exports) of Faeroe Islands in 2009 to that in 2011?
Offer a very short reply. 1.08. What is the ratio of the Balance of Payment (as % of service exports) in Lao PDR in 2009 to that in 2011?
Ensure brevity in your answer.  1.09. What is the ratio of the Balance of Payment (as % of service exports) of Namibia in 2009 to that in 2011?
Your answer should be compact. 0.91. What is the ratio of the Balance of Payment (as % of service exports) of Bhutan in 2010 to that in 2011?
Your answer should be very brief. 0.95. What is the ratio of the Balance of Payment (as % of service exports) in Faeroe Islands in 2010 to that in 2011?
Give a very brief answer. 1.12. What is the ratio of the Balance of Payment (as % of service exports) in Lao PDR in 2010 to that in 2011?
Provide a succinct answer. 1.17. What is the ratio of the Balance of Payment (as % of service exports) of Namibia in 2010 to that in 2011?
Offer a very short reply. 1.02. What is the difference between the highest and the second highest Balance of Payment (as % of service exports) of Bhutan?
Give a very brief answer. 1.91. What is the difference between the highest and the second highest Balance of Payment (as % of service exports) of Faeroe Islands?
Provide a short and direct response. 6.3. What is the difference between the highest and the second highest Balance of Payment (as % of service exports) in Lao PDR?
Provide a succinct answer. 1. What is the difference between the highest and the second highest Balance of Payment (as % of service exports) in Namibia?
Your answer should be compact. 0.75. What is the difference between the highest and the lowest Balance of Payment (as % of service exports) in Bhutan?
Offer a very short reply. 20.83. What is the difference between the highest and the lowest Balance of Payment (as % of service exports) in Faeroe Islands?
Offer a terse response. 18.86. What is the difference between the highest and the lowest Balance of Payment (as % of service exports) of Lao PDR?
Your answer should be compact. 6.6. What is the difference between the highest and the lowest Balance of Payment (as % of service exports) of Namibia?
Offer a terse response. 2.87. 